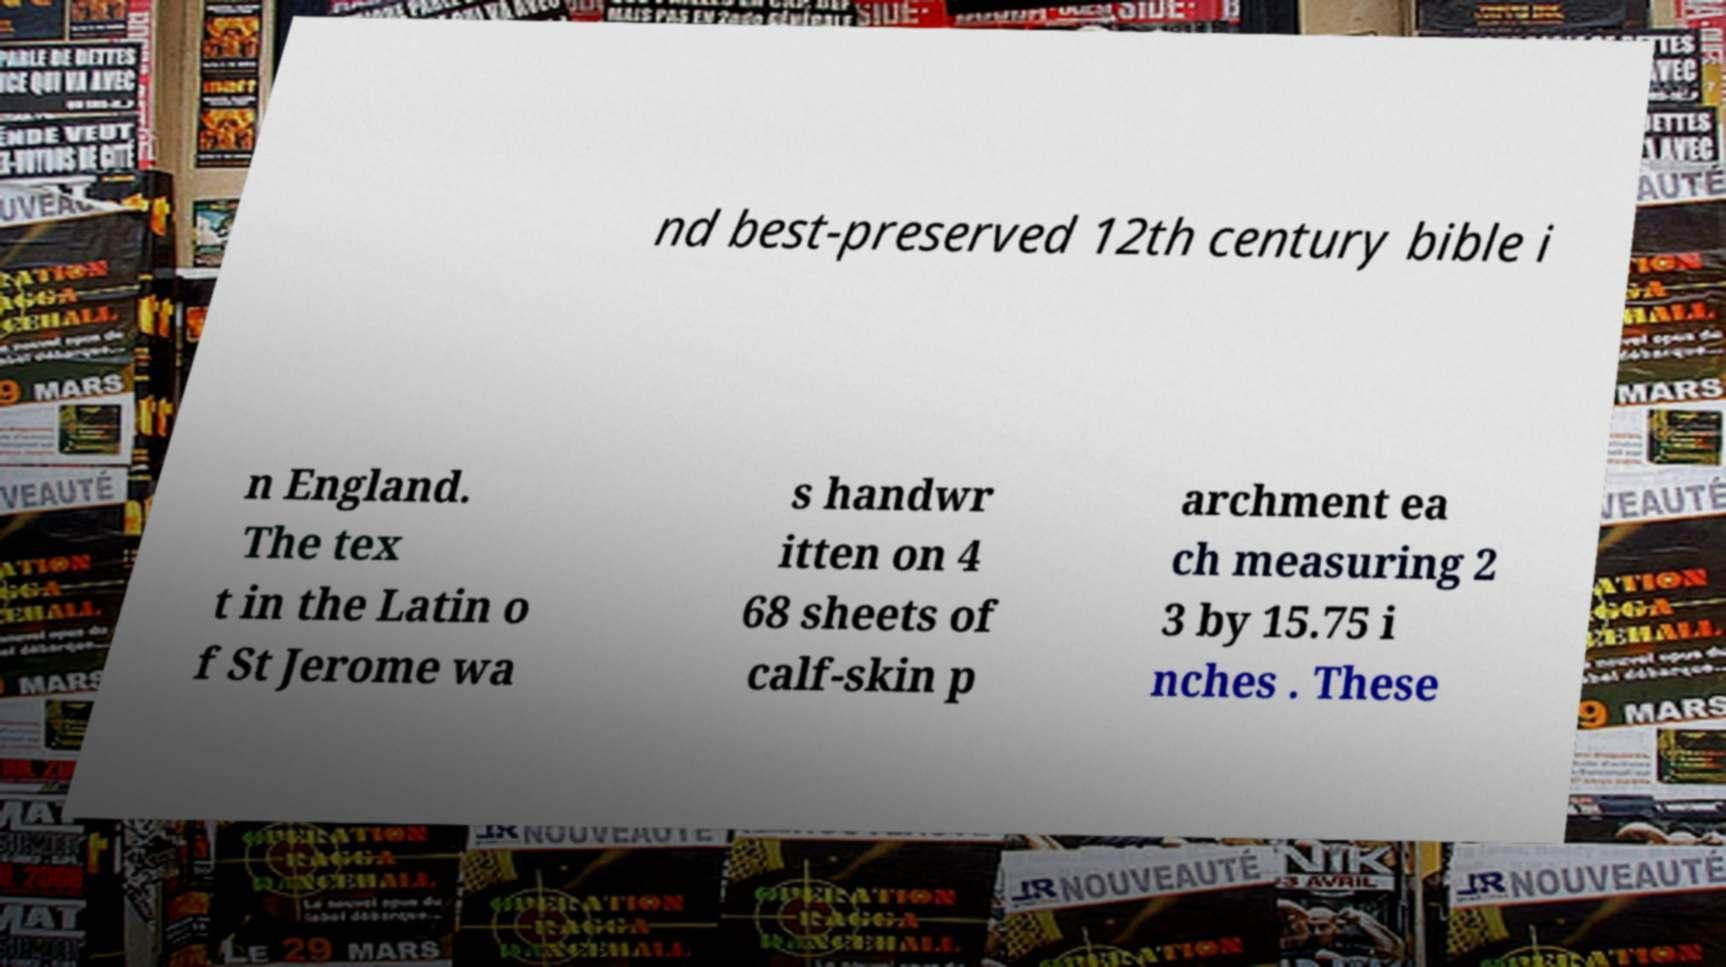Can you read and provide the text displayed in the image?This photo seems to have some interesting text. Can you extract and type it out for me? nd best-preserved 12th century bible i n England. The tex t in the Latin o f St Jerome wa s handwr itten on 4 68 sheets of calf-skin p archment ea ch measuring 2 3 by 15.75 i nches . These 